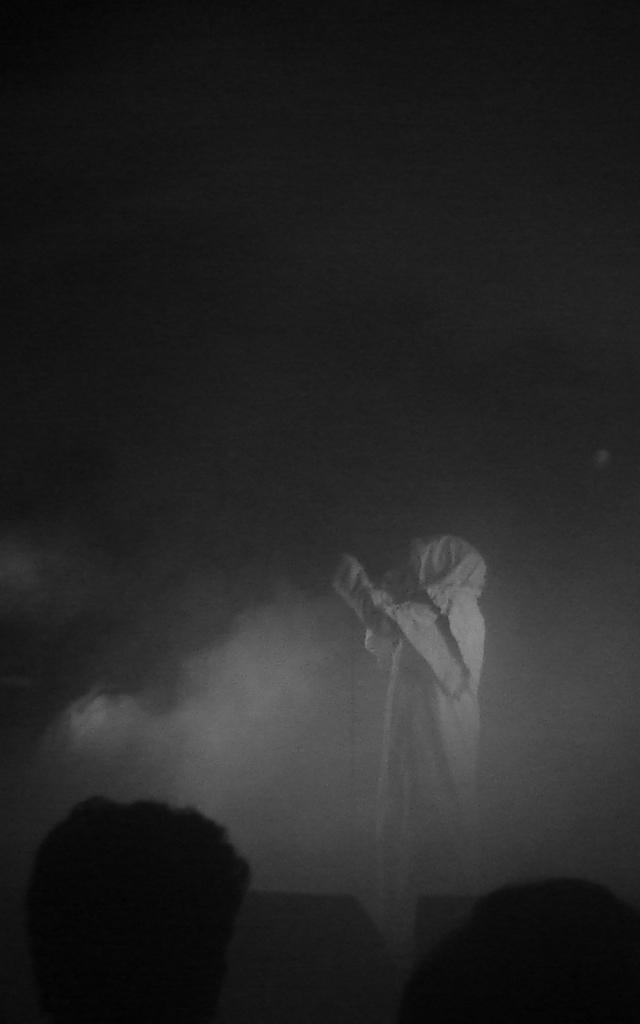Please provide a concise description of this image. The image is looking like an edited image. In the center we can see an object looking like a person. In this picture there is smoke. 